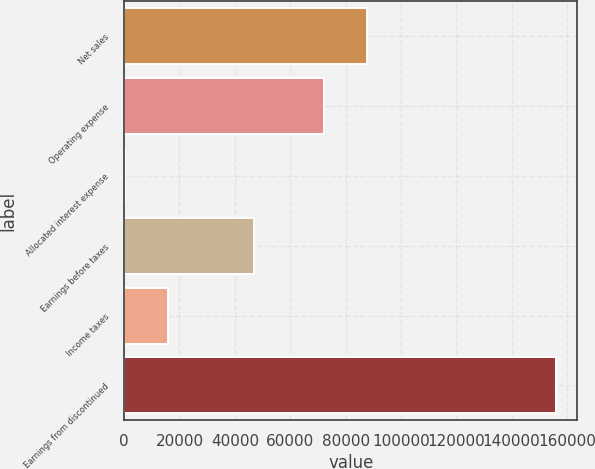Convert chart. <chart><loc_0><loc_0><loc_500><loc_500><bar_chart><fcel>Net sales<fcel>Operating expense<fcel>Allocated interest expense<fcel>Earnings before taxes<fcel>Income taxes<fcel>Earnings from discontinued<nl><fcel>87794.5<fcel>72239<fcel>351<fcel>47017.5<fcel>15906.5<fcel>155906<nl></chart> 